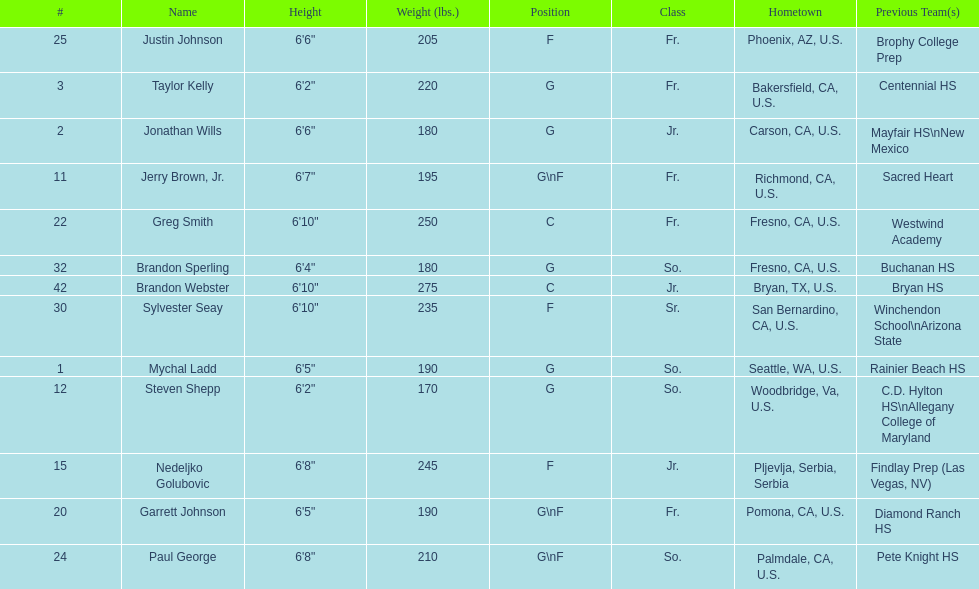Who is the only player not from the u. s.? Nedeljko Golubovic. 